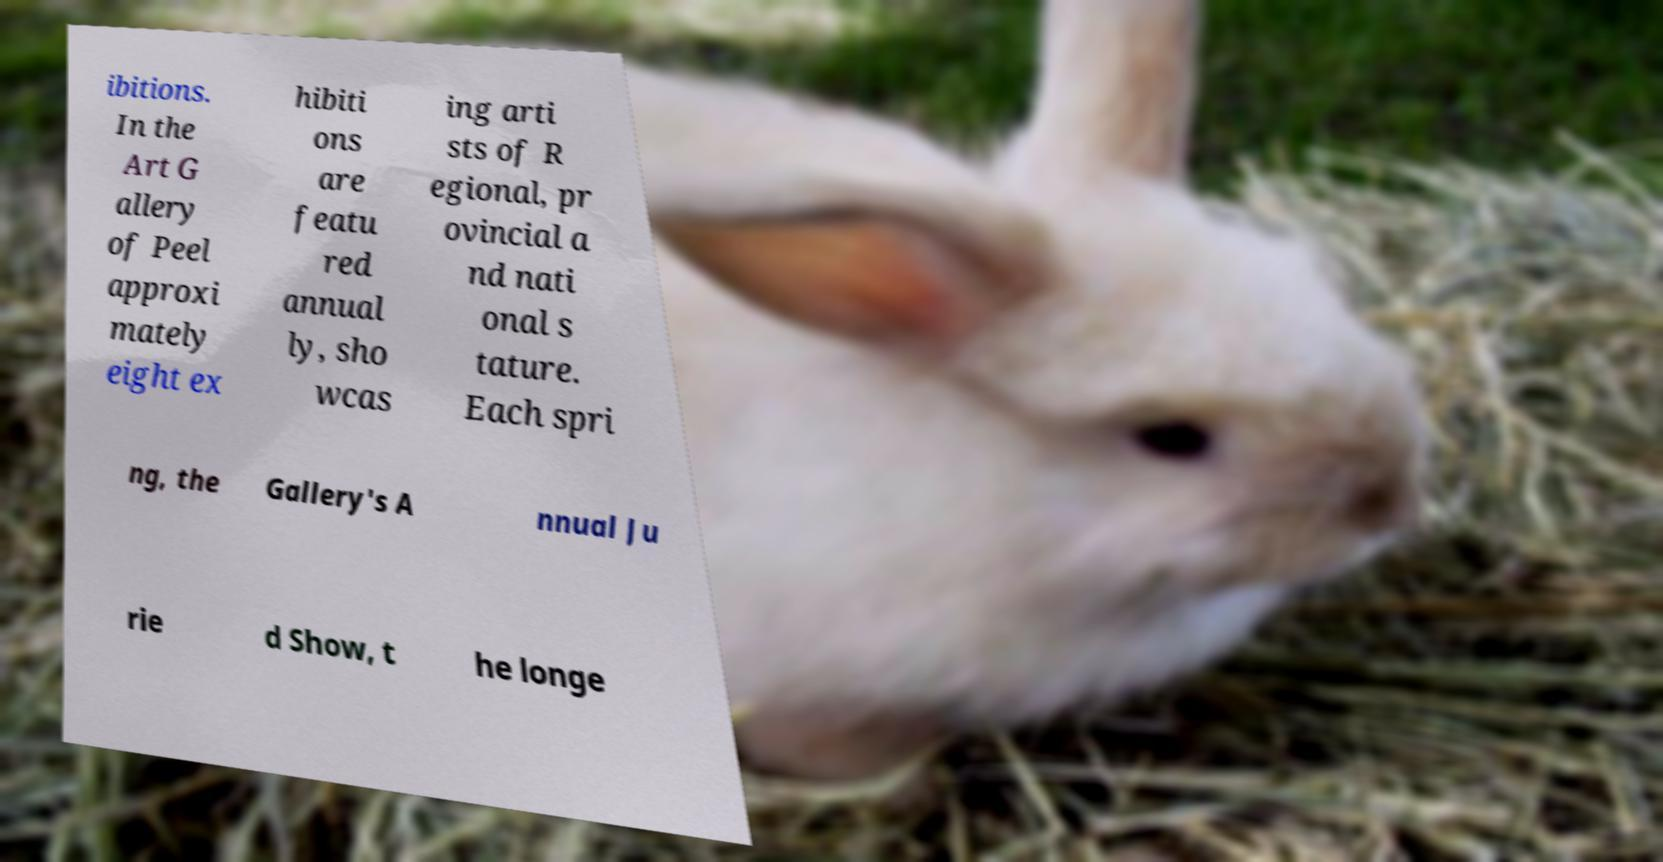For documentation purposes, I need the text within this image transcribed. Could you provide that? ibitions. In the Art G allery of Peel approxi mately eight ex hibiti ons are featu red annual ly, sho wcas ing arti sts of R egional, pr ovincial a nd nati onal s tature. Each spri ng, the Gallery's A nnual Ju rie d Show, t he longe 